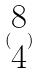<formula> <loc_0><loc_0><loc_500><loc_500>( \begin{matrix} 8 \\ 4 \end{matrix} )</formula> 